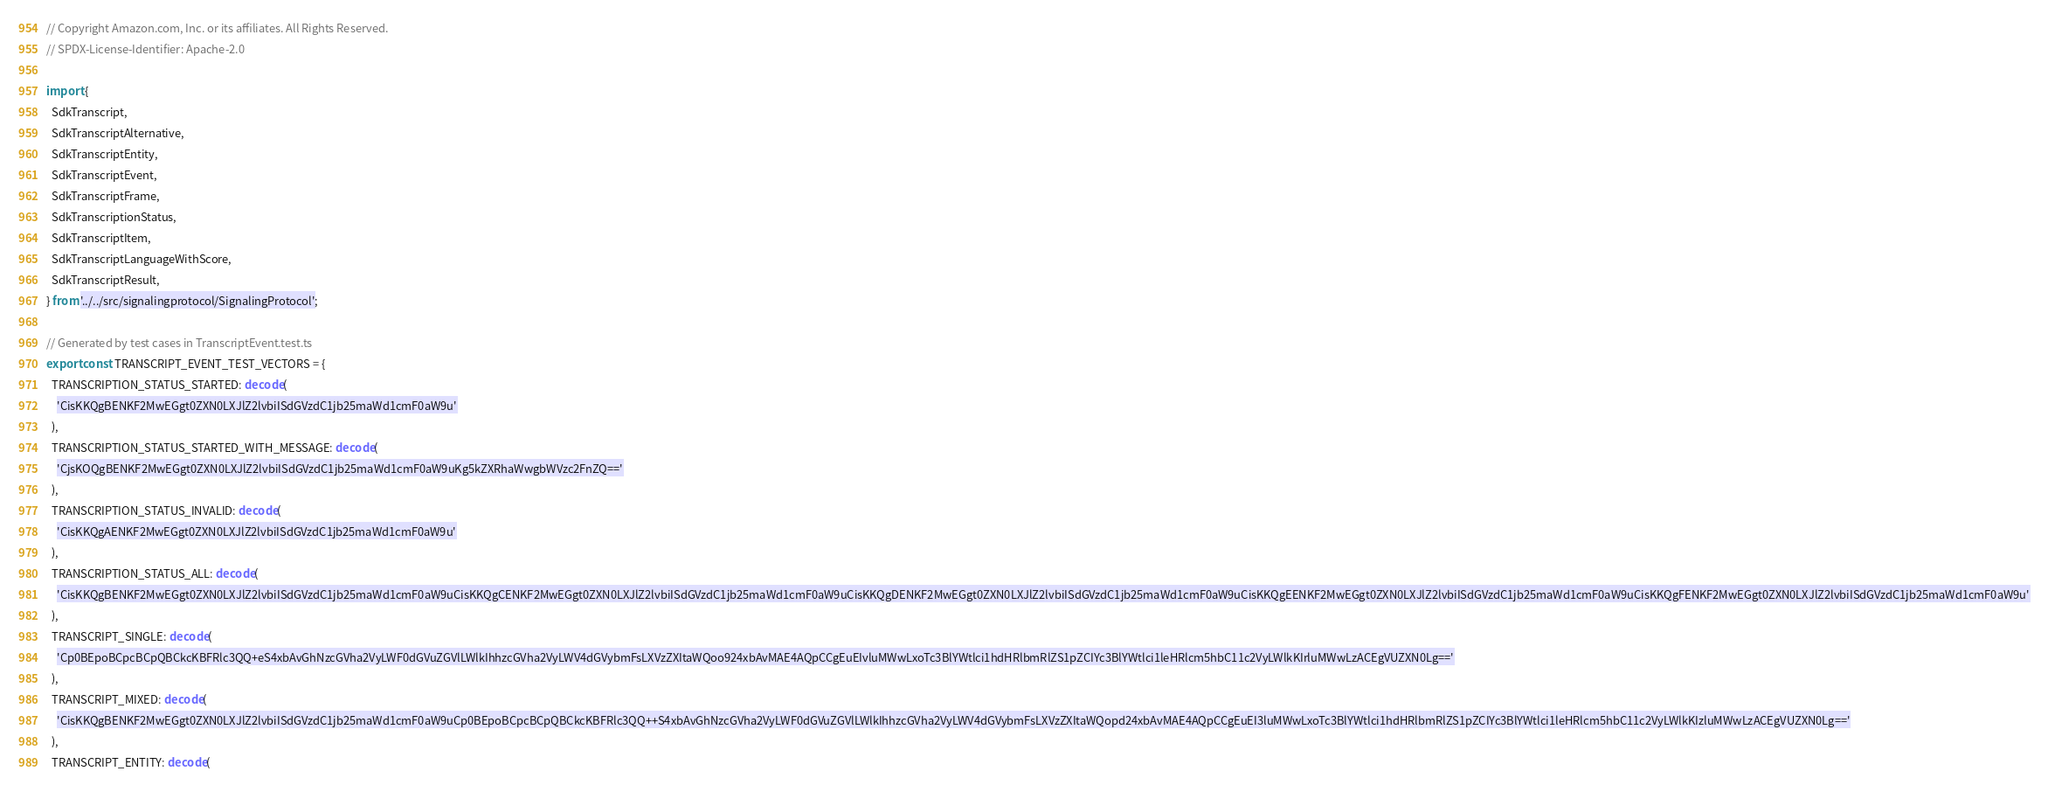<code> <loc_0><loc_0><loc_500><loc_500><_TypeScript_>// Copyright Amazon.com, Inc. or its affiliates. All Rights Reserved.
// SPDX-License-Identifier: Apache-2.0

import {
  SdkTranscript,
  SdkTranscriptAlternative,
  SdkTranscriptEntity,
  SdkTranscriptEvent,
  SdkTranscriptFrame,
  SdkTranscriptionStatus,
  SdkTranscriptItem,
  SdkTranscriptLanguageWithScore,
  SdkTranscriptResult,
} from '../../src/signalingprotocol/SignalingProtocol';

// Generated by test cases in TranscriptEvent.test.ts
export const TRANSCRIPT_EVENT_TEST_VECTORS = {
  TRANSCRIPTION_STATUS_STARTED: decode(
    'CisKKQgBENKF2MwEGgt0ZXN0LXJlZ2lvbiISdGVzdC1jb25maWd1cmF0aW9u'
  ),
  TRANSCRIPTION_STATUS_STARTED_WITH_MESSAGE: decode(
    'CjsKOQgBENKF2MwEGgt0ZXN0LXJlZ2lvbiISdGVzdC1jb25maWd1cmF0aW9uKg5kZXRhaWwgbWVzc2FnZQ=='
  ),
  TRANSCRIPTION_STATUS_INVALID: decode(
    'CisKKQgAENKF2MwEGgt0ZXN0LXJlZ2lvbiISdGVzdC1jb25maWd1cmF0aW9u'
  ),
  TRANSCRIPTION_STATUS_ALL: decode(
    'CisKKQgBENKF2MwEGgt0ZXN0LXJlZ2lvbiISdGVzdC1jb25maWd1cmF0aW9uCisKKQgCENKF2MwEGgt0ZXN0LXJlZ2lvbiISdGVzdC1jb25maWd1cmF0aW9uCisKKQgDENKF2MwEGgt0ZXN0LXJlZ2lvbiISdGVzdC1jb25maWd1cmF0aW9uCisKKQgEENKF2MwEGgt0ZXN0LXJlZ2lvbiISdGVzdC1jb25maWd1cmF0aW9uCisKKQgFENKF2MwEGgt0ZXN0LXJlZ2lvbiISdGVzdC1jb25maWd1cmF0aW9u'
  ),
  TRANSCRIPT_SINGLE: decode(
    'Cp0BEpoBCpcBCpQBCkcKBFRlc3QQ+eS4xbAvGhNzcGVha2VyLWF0dGVuZGVlLWlkIhhzcGVha2VyLWV4dGVybmFsLXVzZXItaWQoo924xbAvMAE4AQpCCgEuEIvluMWwLxoTc3BlYWtlci1hdHRlbmRlZS1pZCIYc3BlYWtlci1leHRlcm5hbC11c2VyLWlkKIrluMWwLzACEgVUZXN0Lg=='
  ),
  TRANSCRIPT_MIXED: decode(
    'CisKKQgBENKF2MwEGgt0ZXN0LXJlZ2lvbiISdGVzdC1jb25maWd1cmF0aW9uCp0BEpoBCpcBCpQBCkcKBFRlc3QQ++S4xbAvGhNzcGVha2VyLWF0dGVuZGVlLWlkIhhzcGVha2VyLWV4dGVybmFsLXVzZXItaWQopd24xbAvMAE4AQpCCgEuEI3luMWwLxoTc3BlYWtlci1hdHRlbmRlZS1pZCIYc3BlYWtlci1leHRlcm5hbC11c2VyLWlkKIzluMWwLzACEgVUZXN0Lg=='
  ),
  TRANSCRIPT_ENTITY: decode(</code> 